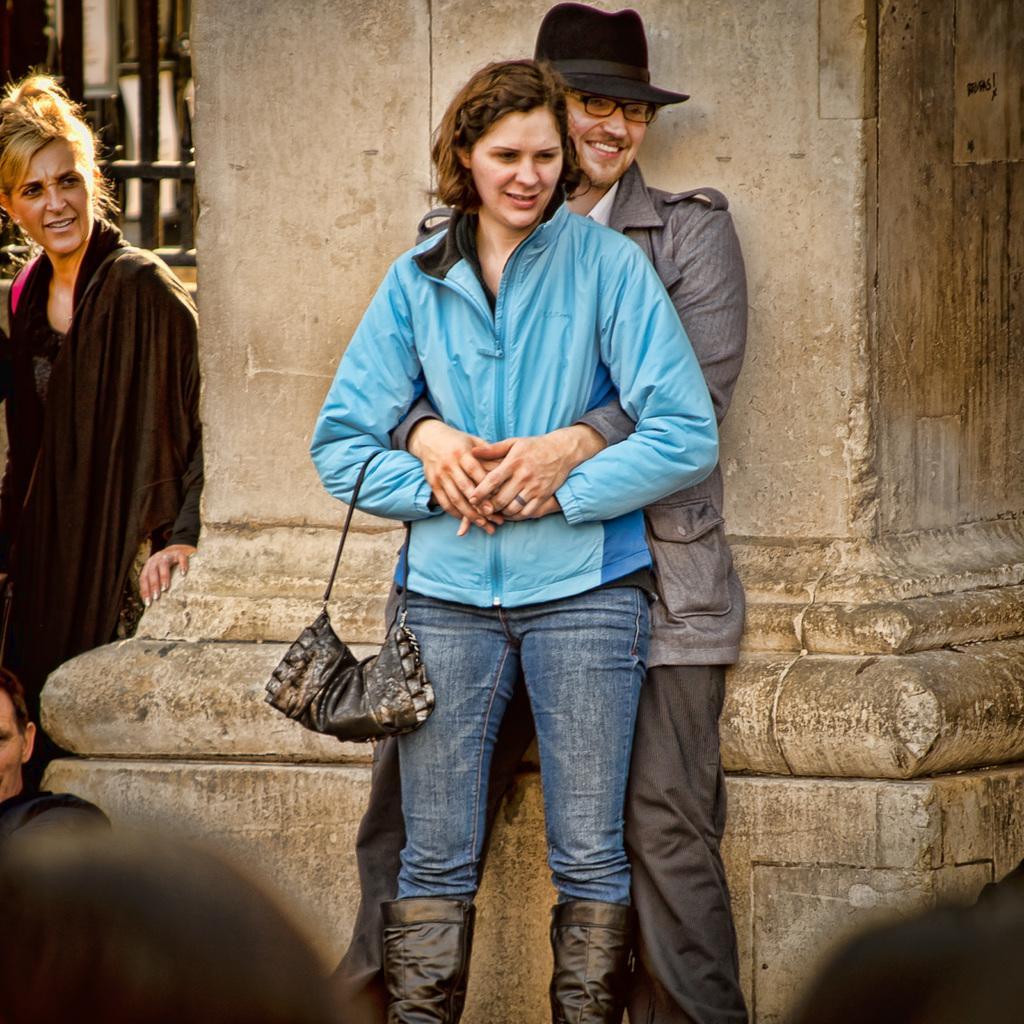Could you give a brief overview of what you see in this image? In this image, we can see two persons in front of the pillar. These two persons are standing and wearing clothes. There is an another person on the left side of the image wearing clothes. 